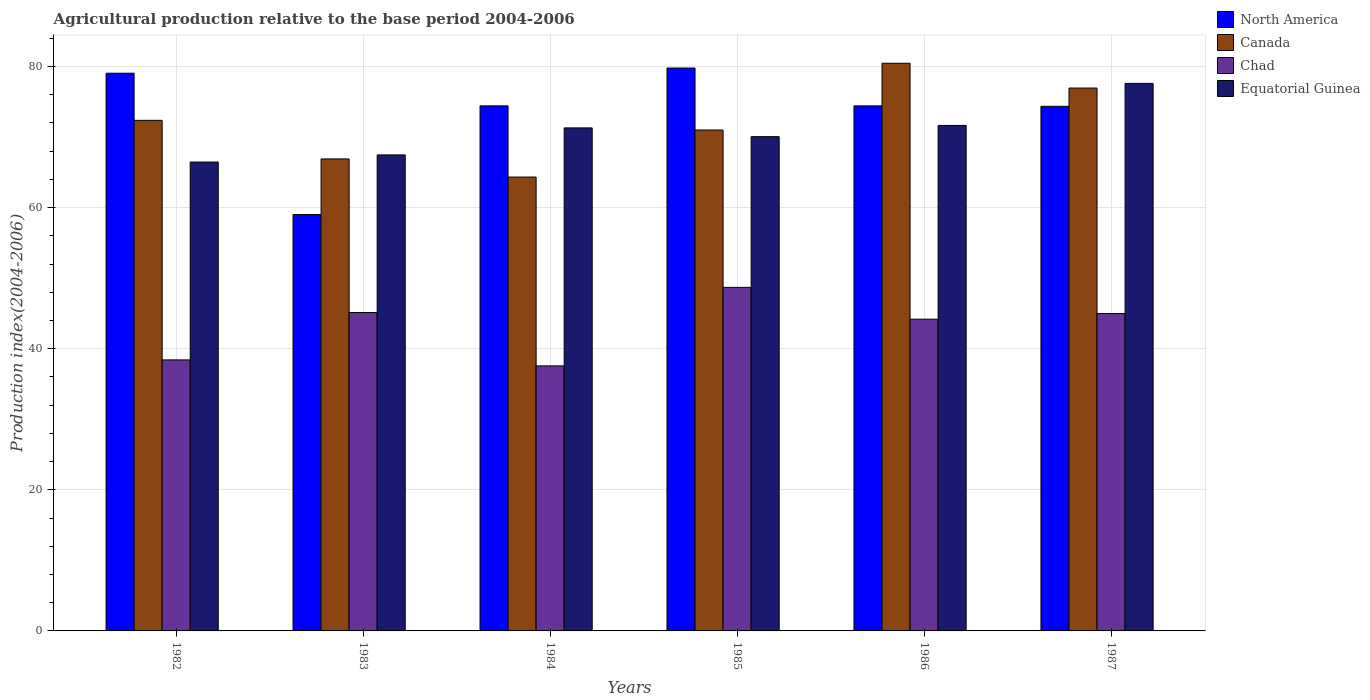How many different coloured bars are there?
Ensure brevity in your answer.  4. How many groups of bars are there?
Offer a terse response. 6. In how many cases, is the number of bars for a given year not equal to the number of legend labels?
Offer a terse response. 0. What is the agricultural production index in North America in 1985?
Ensure brevity in your answer.  79.77. Across all years, what is the maximum agricultural production index in North America?
Give a very brief answer. 79.77. Across all years, what is the minimum agricultural production index in North America?
Your response must be concise. 59.01. What is the total agricultural production index in Chad in the graph?
Provide a succinct answer. 258.94. What is the difference between the agricultural production index in Canada in 1986 and that in 1987?
Provide a short and direct response. 3.51. What is the difference between the agricultural production index in Canada in 1985 and the agricultural production index in Equatorial Guinea in 1984?
Keep it short and to the point. -0.3. What is the average agricultural production index in Canada per year?
Make the answer very short. 71.99. In the year 1983, what is the difference between the agricultural production index in Equatorial Guinea and agricultural production index in Chad?
Offer a terse response. 22.34. What is the ratio of the agricultural production index in North America in 1985 to that in 1986?
Ensure brevity in your answer.  1.07. What is the difference between the highest and the second highest agricultural production index in Equatorial Guinea?
Your answer should be very brief. 5.96. What is the difference between the highest and the lowest agricultural production index in Canada?
Offer a terse response. 16.13. Is the sum of the agricultural production index in North America in 1982 and 1983 greater than the maximum agricultural production index in Chad across all years?
Provide a succinct answer. Yes. What does the 4th bar from the left in 1983 represents?
Provide a succinct answer. Equatorial Guinea. How many years are there in the graph?
Provide a succinct answer. 6. What is the difference between two consecutive major ticks on the Y-axis?
Offer a terse response. 20. Does the graph contain any zero values?
Your response must be concise. No. Where does the legend appear in the graph?
Your answer should be compact. Top right. How many legend labels are there?
Offer a very short reply. 4. What is the title of the graph?
Make the answer very short. Agricultural production relative to the base period 2004-2006. What is the label or title of the Y-axis?
Offer a terse response. Production index(2004-2006). What is the Production index(2004-2006) of North America in 1982?
Offer a very short reply. 79.04. What is the Production index(2004-2006) of Canada in 1982?
Keep it short and to the point. 72.36. What is the Production index(2004-2006) in Chad in 1982?
Provide a succinct answer. 38.41. What is the Production index(2004-2006) of Equatorial Guinea in 1982?
Offer a terse response. 66.45. What is the Production index(2004-2006) of North America in 1983?
Your answer should be very brief. 59.01. What is the Production index(2004-2006) of Canada in 1983?
Offer a very short reply. 66.89. What is the Production index(2004-2006) in Chad in 1983?
Your answer should be compact. 45.12. What is the Production index(2004-2006) in Equatorial Guinea in 1983?
Your answer should be very brief. 67.46. What is the Production index(2004-2006) in North America in 1984?
Give a very brief answer. 74.41. What is the Production index(2004-2006) in Canada in 1984?
Offer a very short reply. 64.32. What is the Production index(2004-2006) in Chad in 1984?
Offer a terse response. 37.56. What is the Production index(2004-2006) in Equatorial Guinea in 1984?
Make the answer very short. 71.29. What is the Production index(2004-2006) of North America in 1985?
Offer a very short reply. 79.77. What is the Production index(2004-2006) of Canada in 1985?
Keep it short and to the point. 70.99. What is the Production index(2004-2006) of Chad in 1985?
Ensure brevity in your answer.  48.69. What is the Production index(2004-2006) of Equatorial Guinea in 1985?
Provide a succinct answer. 70.05. What is the Production index(2004-2006) of North America in 1986?
Provide a short and direct response. 74.41. What is the Production index(2004-2006) in Canada in 1986?
Your answer should be very brief. 80.45. What is the Production index(2004-2006) of Chad in 1986?
Provide a succinct answer. 44.18. What is the Production index(2004-2006) of Equatorial Guinea in 1986?
Provide a succinct answer. 71.64. What is the Production index(2004-2006) of North America in 1987?
Offer a terse response. 74.35. What is the Production index(2004-2006) of Canada in 1987?
Keep it short and to the point. 76.94. What is the Production index(2004-2006) in Chad in 1987?
Offer a very short reply. 44.98. What is the Production index(2004-2006) of Equatorial Guinea in 1987?
Your answer should be compact. 77.6. Across all years, what is the maximum Production index(2004-2006) of North America?
Keep it short and to the point. 79.77. Across all years, what is the maximum Production index(2004-2006) in Canada?
Offer a very short reply. 80.45. Across all years, what is the maximum Production index(2004-2006) in Chad?
Your response must be concise. 48.69. Across all years, what is the maximum Production index(2004-2006) in Equatorial Guinea?
Your response must be concise. 77.6. Across all years, what is the minimum Production index(2004-2006) of North America?
Provide a succinct answer. 59.01. Across all years, what is the minimum Production index(2004-2006) in Canada?
Your answer should be very brief. 64.32. Across all years, what is the minimum Production index(2004-2006) of Chad?
Give a very brief answer. 37.56. Across all years, what is the minimum Production index(2004-2006) of Equatorial Guinea?
Give a very brief answer. 66.45. What is the total Production index(2004-2006) of North America in the graph?
Provide a succinct answer. 440.99. What is the total Production index(2004-2006) of Canada in the graph?
Offer a very short reply. 431.95. What is the total Production index(2004-2006) of Chad in the graph?
Ensure brevity in your answer.  258.94. What is the total Production index(2004-2006) of Equatorial Guinea in the graph?
Your response must be concise. 424.49. What is the difference between the Production index(2004-2006) in North America in 1982 and that in 1983?
Your answer should be compact. 20.03. What is the difference between the Production index(2004-2006) of Canada in 1982 and that in 1983?
Your response must be concise. 5.47. What is the difference between the Production index(2004-2006) in Chad in 1982 and that in 1983?
Make the answer very short. -6.71. What is the difference between the Production index(2004-2006) of Equatorial Guinea in 1982 and that in 1983?
Keep it short and to the point. -1.01. What is the difference between the Production index(2004-2006) in North America in 1982 and that in 1984?
Make the answer very short. 4.63. What is the difference between the Production index(2004-2006) in Canada in 1982 and that in 1984?
Give a very brief answer. 8.04. What is the difference between the Production index(2004-2006) in Chad in 1982 and that in 1984?
Provide a short and direct response. 0.85. What is the difference between the Production index(2004-2006) of Equatorial Guinea in 1982 and that in 1984?
Your answer should be very brief. -4.84. What is the difference between the Production index(2004-2006) in North America in 1982 and that in 1985?
Provide a short and direct response. -0.74. What is the difference between the Production index(2004-2006) of Canada in 1982 and that in 1985?
Provide a short and direct response. 1.37. What is the difference between the Production index(2004-2006) of Chad in 1982 and that in 1985?
Your answer should be compact. -10.28. What is the difference between the Production index(2004-2006) in North America in 1982 and that in 1986?
Offer a terse response. 4.63. What is the difference between the Production index(2004-2006) of Canada in 1982 and that in 1986?
Ensure brevity in your answer.  -8.09. What is the difference between the Production index(2004-2006) of Chad in 1982 and that in 1986?
Offer a very short reply. -5.77. What is the difference between the Production index(2004-2006) in Equatorial Guinea in 1982 and that in 1986?
Provide a succinct answer. -5.19. What is the difference between the Production index(2004-2006) of North America in 1982 and that in 1987?
Offer a very short reply. 4.69. What is the difference between the Production index(2004-2006) in Canada in 1982 and that in 1987?
Ensure brevity in your answer.  -4.58. What is the difference between the Production index(2004-2006) of Chad in 1982 and that in 1987?
Provide a succinct answer. -6.57. What is the difference between the Production index(2004-2006) in Equatorial Guinea in 1982 and that in 1987?
Provide a succinct answer. -11.15. What is the difference between the Production index(2004-2006) in North America in 1983 and that in 1984?
Ensure brevity in your answer.  -15.4. What is the difference between the Production index(2004-2006) in Canada in 1983 and that in 1984?
Your response must be concise. 2.57. What is the difference between the Production index(2004-2006) of Chad in 1983 and that in 1984?
Offer a terse response. 7.56. What is the difference between the Production index(2004-2006) in Equatorial Guinea in 1983 and that in 1984?
Your response must be concise. -3.83. What is the difference between the Production index(2004-2006) of North America in 1983 and that in 1985?
Ensure brevity in your answer.  -20.76. What is the difference between the Production index(2004-2006) of Chad in 1983 and that in 1985?
Your answer should be compact. -3.57. What is the difference between the Production index(2004-2006) in Equatorial Guinea in 1983 and that in 1985?
Your answer should be very brief. -2.59. What is the difference between the Production index(2004-2006) of North America in 1983 and that in 1986?
Provide a short and direct response. -15.4. What is the difference between the Production index(2004-2006) of Canada in 1983 and that in 1986?
Provide a short and direct response. -13.56. What is the difference between the Production index(2004-2006) in Equatorial Guinea in 1983 and that in 1986?
Your answer should be very brief. -4.18. What is the difference between the Production index(2004-2006) of North America in 1983 and that in 1987?
Offer a terse response. -15.34. What is the difference between the Production index(2004-2006) of Canada in 1983 and that in 1987?
Offer a terse response. -10.05. What is the difference between the Production index(2004-2006) in Chad in 1983 and that in 1987?
Your answer should be very brief. 0.14. What is the difference between the Production index(2004-2006) in Equatorial Guinea in 1983 and that in 1987?
Keep it short and to the point. -10.14. What is the difference between the Production index(2004-2006) of North America in 1984 and that in 1985?
Give a very brief answer. -5.36. What is the difference between the Production index(2004-2006) in Canada in 1984 and that in 1985?
Your answer should be compact. -6.67. What is the difference between the Production index(2004-2006) in Chad in 1984 and that in 1985?
Keep it short and to the point. -11.13. What is the difference between the Production index(2004-2006) of Equatorial Guinea in 1984 and that in 1985?
Offer a terse response. 1.24. What is the difference between the Production index(2004-2006) of North America in 1984 and that in 1986?
Your response must be concise. 0. What is the difference between the Production index(2004-2006) of Canada in 1984 and that in 1986?
Offer a terse response. -16.13. What is the difference between the Production index(2004-2006) of Chad in 1984 and that in 1986?
Your answer should be compact. -6.62. What is the difference between the Production index(2004-2006) of Equatorial Guinea in 1984 and that in 1986?
Your answer should be very brief. -0.35. What is the difference between the Production index(2004-2006) in North America in 1984 and that in 1987?
Give a very brief answer. 0.06. What is the difference between the Production index(2004-2006) of Canada in 1984 and that in 1987?
Keep it short and to the point. -12.62. What is the difference between the Production index(2004-2006) in Chad in 1984 and that in 1987?
Your response must be concise. -7.42. What is the difference between the Production index(2004-2006) in Equatorial Guinea in 1984 and that in 1987?
Your response must be concise. -6.31. What is the difference between the Production index(2004-2006) of North America in 1985 and that in 1986?
Your answer should be very brief. 5.37. What is the difference between the Production index(2004-2006) of Canada in 1985 and that in 1986?
Keep it short and to the point. -9.46. What is the difference between the Production index(2004-2006) in Chad in 1985 and that in 1986?
Offer a very short reply. 4.51. What is the difference between the Production index(2004-2006) of Equatorial Guinea in 1985 and that in 1986?
Offer a very short reply. -1.59. What is the difference between the Production index(2004-2006) in North America in 1985 and that in 1987?
Provide a short and direct response. 5.43. What is the difference between the Production index(2004-2006) in Canada in 1985 and that in 1987?
Your answer should be very brief. -5.95. What is the difference between the Production index(2004-2006) of Chad in 1985 and that in 1987?
Make the answer very short. 3.71. What is the difference between the Production index(2004-2006) of Equatorial Guinea in 1985 and that in 1987?
Give a very brief answer. -7.55. What is the difference between the Production index(2004-2006) in North America in 1986 and that in 1987?
Your answer should be very brief. 0.06. What is the difference between the Production index(2004-2006) of Canada in 1986 and that in 1987?
Offer a very short reply. 3.51. What is the difference between the Production index(2004-2006) in Chad in 1986 and that in 1987?
Your response must be concise. -0.8. What is the difference between the Production index(2004-2006) of Equatorial Guinea in 1986 and that in 1987?
Offer a terse response. -5.96. What is the difference between the Production index(2004-2006) in North America in 1982 and the Production index(2004-2006) in Canada in 1983?
Give a very brief answer. 12.15. What is the difference between the Production index(2004-2006) in North America in 1982 and the Production index(2004-2006) in Chad in 1983?
Provide a short and direct response. 33.92. What is the difference between the Production index(2004-2006) in North America in 1982 and the Production index(2004-2006) in Equatorial Guinea in 1983?
Give a very brief answer. 11.58. What is the difference between the Production index(2004-2006) of Canada in 1982 and the Production index(2004-2006) of Chad in 1983?
Provide a short and direct response. 27.24. What is the difference between the Production index(2004-2006) of Canada in 1982 and the Production index(2004-2006) of Equatorial Guinea in 1983?
Make the answer very short. 4.9. What is the difference between the Production index(2004-2006) of Chad in 1982 and the Production index(2004-2006) of Equatorial Guinea in 1983?
Ensure brevity in your answer.  -29.05. What is the difference between the Production index(2004-2006) of North America in 1982 and the Production index(2004-2006) of Canada in 1984?
Offer a very short reply. 14.72. What is the difference between the Production index(2004-2006) of North America in 1982 and the Production index(2004-2006) of Chad in 1984?
Your answer should be compact. 41.48. What is the difference between the Production index(2004-2006) of North America in 1982 and the Production index(2004-2006) of Equatorial Guinea in 1984?
Ensure brevity in your answer.  7.75. What is the difference between the Production index(2004-2006) of Canada in 1982 and the Production index(2004-2006) of Chad in 1984?
Your answer should be very brief. 34.8. What is the difference between the Production index(2004-2006) of Canada in 1982 and the Production index(2004-2006) of Equatorial Guinea in 1984?
Provide a short and direct response. 1.07. What is the difference between the Production index(2004-2006) of Chad in 1982 and the Production index(2004-2006) of Equatorial Guinea in 1984?
Provide a short and direct response. -32.88. What is the difference between the Production index(2004-2006) of North America in 1982 and the Production index(2004-2006) of Canada in 1985?
Make the answer very short. 8.05. What is the difference between the Production index(2004-2006) in North America in 1982 and the Production index(2004-2006) in Chad in 1985?
Your response must be concise. 30.35. What is the difference between the Production index(2004-2006) of North America in 1982 and the Production index(2004-2006) of Equatorial Guinea in 1985?
Offer a terse response. 8.99. What is the difference between the Production index(2004-2006) of Canada in 1982 and the Production index(2004-2006) of Chad in 1985?
Ensure brevity in your answer.  23.67. What is the difference between the Production index(2004-2006) in Canada in 1982 and the Production index(2004-2006) in Equatorial Guinea in 1985?
Your response must be concise. 2.31. What is the difference between the Production index(2004-2006) in Chad in 1982 and the Production index(2004-2006) in Equatorial Guinea in 1985?
Ensure brevity in your answer.  -31.64. What is the difference between the Production index(2004-2006) of North America in 1982 and the Production index(2004-2006) of Canada in 1986?
Provide a succinct answer. -1.41. What is the difference between the Production index(2004-2006) in North America in 1982 and the Production index(2004-2006) in Chad in 1986?
Your answer should be very brief. 34.86. What is the difference between the Production index(2004-2006) in North America in 1982 and the Production index(2004-2006) in Equatorial Guinea in 1986?
Give a very brief answer. 7.4. What is the difference between the Production index(2004-2006) of Canada in 1982 and the Production index(2004-2006) of Chad in 1986?
Ensure brevity in your answer.  28.18. What is the difference between the Production index(2004-2006) of Canada in 1982 and the Production index(2004-2006) of Equatorial Guinea in 1986?
Offer a terse response. 0.72. What is the difference between the Production index(2004-2006) in Chad in 1982 and the Production index(2004-2006) in Equatorial Guinea in 1986?
Offer a very short reply. -33.23. What is the difference between the Production index(2004-2006) in North America in 1982 and the Production index(2004-2006) in Canada in 1987?
Your answer should be compact. 2.1. What is the difference between the Production index(2004-2006) in North America in 1982 and the Production index(2004-2006) in Chad in 1987?
Offer a terse response. 34.06. What is the difference between the Production index(2004-2006) in North America in 1982 and the Production index(2004-2006) in Equatorial Guinea in 1987?
Offer a very short reply. 1.44. What is the difference between the Production index(2004-2006) of Canada in 1982 and the Production index(2004-2006) of Chad in 1987?
Ensure brevity in your answer.  27.38. What is the difference between the Production index(2004-2006) in Canada in 1982 and the Production index(2004-2006) in Equatorial Guinea in 1987?
Your answer should be compact. -5.24. What is the difference between the Production index(2004-2006) of Chad in 1982 and the Production index(2004-2006) of Equatorial Guinea in 1987?
Provide a succinct answer. -39.19. What is the difference between the Production index(2004-2006) of North America in 1983 and the Production index(2004-2006) of Canada in 1984?
Ensure brevity in your answer.  -5.31. What is the difference between the Production index(2004-2006) of North America in 1983 and the Production index(2004-2006) of Chad in 1984?
Keep it short and to the point. 21.45. What is the difference between the Production index(2004-2006) of North America in 1983 and the Production index(2004-2006) of Equatorial Guinea in 1984?
Provide a succinct answer. -12.28. What is the difference between the Production index(2004-2006) of Canada in 1983 and the Production index(2004-2006) of Chad in 1984?
Ensure brevity in your answer.  29.33. What is the difference between the Production index(2004-2006) of Chad in 1983 and the Production index(2004-2006) of Equatorial Guinea in 1984?
Offer a terse response. -26.17. What is the difference between the Production index(2004-2006) in North America in 1983 and the Production index(2004-2006) in Canada in 1985?
Ensure brevity in your answer.  -11.98. What is the difference between the Production index(2004-2006) of North America in 1983 and the Production index(2004-2006) of Chad in 1985?
Make the answer very short. 10.32. What is the difference between the Production index(2004-2006) of North America in 1983 and the Production index(2004-2006) of Equatorial Guinea in 1985?
Keep it short and to the point. -11.04. What is the difference between the Production index(2004-2006) of Canada in 1983 and the Production index(2004-2006) of Chad in 1985?
Keep it short and to the point. 18.2. What is the difference between the Production index(2004-2006) of Canada in 1983 and the Production index(2004-2006) of Equatorial Guinea in 1985?
Ensure brevity in your answer.  -3.16. What is the difference between the Production index(2004-2006) in Chad in 1983 and the Production index(2004-2006) in Equatorial Guinea in 1985?
Provide a succinct answer. -24.93. What is the difference between the Production index(2004-2006) in North America in 1983 and the Production index(2004-2006) in Canada in 1986?
Ensure brevity in your answer.  -21.44. What is the difference between the Production index(2004-2006) of North America in 1983 and the Production index(2004-2006) of Chad in 1986?
Provide a succinct answer. 14.83. What is the difference between the Production index(2004-2006) in North America in 1983 and the Production index(2004-2006) in Equatorial Guinea in 1986?
Your answer should be compact. -12.63. What is the difference between the Production index(2004-2006) of Canada in 1983 and the Production index(2004-2006) of Chad in 1986?
Provide a succinct answer. 22.71. What is the difference between the Production index(2004-2006) in Canada in 1983 and the Production index(2004-2006) in Equatorial Guinea in 1986?
Offer a very short reply. -4.75. What is the difference between the Production index(2004-2006) of Chad in 1983 and the Production index(2004-2006) of Equatorial Guinea in 1986?
Provide a short and direct response. -26.52. What is the difference between the Production index(2004-2006) of North America in 1983 and the Production index(2004-2006) of Canada in 1987?
Your response must be concise. -17.93. What is the difference between the Production index(2004-2006) in North America in 1983 and the Production index(2004-2006) in Chad in 1987?
Give a very brief answer. 14.03. What is the difference between the Production index(2004-2006) in North America in 1983 and the Production index(2004-2006) in Equatorial Guinea in 1987?
Your answer should be very brief. -18.59. What is the difference between the Production index(2004-2006) in Canada in 1983 and the Production index(2004-2006) in Chad in 1987?
Provide a succinct answer. 21.91. What is the difference between the Production index(2004-2006) in Canada in 1983 and the Production index(2004-2006) in Equatorial Guinea in 1987?
Provide a succinct answer. -10.71. What is the difference between the Production index(2004-2006) of Chad in 1983 and the Production index(2004-2006) of Equatorial Guinea in 1987?
Your answer should be compact. -32.48. What is the difference between the Production index(2004-2006) of North America in 1984 and the Production index(2004-2006) of Canada in 1985?
Give a very brief answer. 3.42. What is the difference between the Production index(2004-2006) in North America in 1984 and the Production index(2004-2006) in Chad in 1985?
Offer a very short reply. 25.72. What is the difference between the Production index(2004-2006) of North America in 1984 and the Production index(2004-2006) of Equatorial Guinea in 1985?
Keep it short and to the point. 4.36. What is the difference between the Production index(2004-2006) in Canada in 1984 and the Production index(2004-2006) in Chad in 1985?
Give a very brief answer. 15.63. What is the difference between the Production index(2004-2006) in Canada in 1984 and the Production index(2004-2006) in Equatorial Guinea in 1985?
Provide a succinct answer. -5.73. What is the difference between the Production index(2004-2006) in Chad in 1984 and the Production index(2004-2006) in Equatorial Guinea in 1985?
Provide a succinct answer. -32.49. What is the difference between the Production index(2004-2006) in North America in 1984 and the Production index(2004-2006) in Canada in 1986?
Give a very brief answer. -6.04. What is the difference between the Production index(2004-2006) in North America in 1984 and the Production index(2004-2006) in Chad in 1986?
Provide a succinct answer. 30.23. What is the difference between the Production index(2004-2006) of North America in 1984 and the Production index(2004-2006) of Equatorial Guinea in 1986?
Offer a very short reply. 2.77. What is the difference between the Production index(2004-2006) of Canada in 1984 and the Production index(2004-2006) of Chad in 1986?
Provide a succinct answer. 20.14. What is the difference between the Production index(2004-2006) in Canada in 1984 and the Production index(2004-2006) in Equatorial Guinea in 1986?
Keep it short and to the point. -7.32. What is the difference between the Production index(2004-2006) of Chad in 1984 and the Production index(2004-2006) of Equatorial Guinea in 1986?
Keep it short and to the point. -34.08. What is the difference between the Production index(2004-2006) in North America in 1984 and the Production index(2004-2006) in Canada in 1987?
Your response must be concise. -2.53. What is the difference between the Production index(2004-2006) in North America in 1984 and the Production index(2004-2006) in Chad in 1987?
Your answer should be compact. 29.43. What is the difference between the Production index(2004-2006) of North America in 1984 and the Production index(2004-2006) of Equatorial Guinea in 1987?
Your answer should be compact. -3.19. What is the difference between the Production index(2004-2006) of Canada in 1984 and the Production index(2004-2006) of Chad in 1987?
Your response must be concise. 19.34. What is the difference between the Production index(2004-2006) of Canada in 1984 and the Production index(2004-2006) of Equatorial Guinea in 1987?
Your response must be concise. -13.28. What is the difference between the Production index(2004-2006) in Chad in 1984 and the Production index(2004-2006) in Equatorial Guinea in 1987?
Keep it short and to the point. -40.04. What is the difference between the Production index(2004-2006) in North America in 1985 and the Production index(2004-2006) in Canada in 1986?
Offer a very short reply. -0.68. What is the difference between the Production index(2004-2006) of North America in 1985 and the Production index(2004-2006) of Chad in 1986?
Your answer should be compact. 35.59. What is the difference between the Production index(2004-2006) in North America in 1985 and the Production index(2004-2006) in Equatorial Guinea in 1986?
Provide a succinct answer. 8.13. What is the difference between the Production index(2004-2006) in Canada in 1985 and the Production index(2004-2006) in Chad in 1986?
Give a very brief answer. 26.81. What is the difference between the Production index(2004-2006) of Canada in 1985 and the Production index(2004-2006) of Equatorial Guinea in 1986?
Make the answer very short. -0.65. What is the difference between the Production index(2004-2006) in Chad in 1985 and the Production index(2004-2006) in Equatorial Guinea in 1986?
Keep it short and to the point. -22.95. What is the difference between the Production index(2004-2006) in North America in 1985 and the Production index(2004-2006) in Canada in 1987?
Make the answer very short. 2.83. What is the difference between the Production index(2004-2006) in North America in 1985 and the Production index(2004-2006) in Chad in 1987?
Your response must be concise. 34.79. What is the difference between the Production index(2004-2006) in North America in 1985 and the Production index(2004-2006) in Equatorial Guinea in 1987?
Make the answer very short. 2.17. What is the difference between the Production index(2004-2006) in Canada in 1985 and the Production index(2004-2006) in Chad in 1987?
Keep it short and to the point. 26.01. What is the difference between the Production index(2004-2006) of Canada in 1985 and the Production index(2004-2006) of Equatorial Guinea in 1987?
Offer a terse response. -6.61. What is the difference between the Production index(2004-2006) of Chad in 1985 and the Production index(2004-2006) of Equatorial Guinea in 1987?
Make the answer very short. -28.91. What is the difference between the Production index(2004-2006) of North America in 1986 and the Production index(2004-2006) of Canada in 1987?
Keep it short and to the point. -2.53. What is the difference between the Production index(2004-2006) of North America in 1986 and the Production index(2004-2006) of Chad in 1987?
Offer a very short reply. 29.43. What is the difference between the Production index(2004-2006) of North America in 1986 and the Production index(2004-2006) of Equatorial Guinea in 1987?
Provide a short and direct response. -3.19. What is the difference between the Production index(2004-2006) in Canada in 1986 and the Production index(2004-2006) in Chad in 1987?
Your answer should be very brief. 35.47. What is the difference between the Production index(2004-2006) of Canada in 1986 and the Production index(2004-2006) of Equatorial Guinea in 1987?
Your answer should be compact. 2.85. What is the difference between the Production index(2004-2006) of Chad in 1986 and the Production index(2004-2006) of Equatorial Guinea in 1987?
Offer a very short reply. -33.42. What is the average Production index(2004-2006) in North America per year?
Keep it short and to the point. 73.5. What is the average Production index(2004-2006) in Canada per year?
Give a very brief answer. 71.99. What is the average Production index(2004-2006) of Chad per year?
Provide a succinct answer. 43.16. What is the average Production index(2004-2006) of Equatorial Guinea per year?
Provide a succinct answer. 70.75. In the year 1982, what is the difference between the Production index(2004-2006) of North America and Production index(2004-2006) of Canada?
Ensure brevity in your answer.  6.68. In the year 1982, what is the difference between the Production index(2004-2006) in North America and Production index(2004-2006) in Chad?
Offer a very short reply. 40.63. In the year 1982, what is the difference between the Production index(2004-2006) in North America and Production index(2004-2006) in Equatorial Guinea?
Provide a succinct answer. 12.59. In the year 1982, what is the difference between the Production index(2004-2006) in Canada and Production index(2004-2006) in Chad?
Make the answer very short. 33.95. In the year 1982, what is the difference between the Production index(2004-2006) of Canada and Production index(2004-2006) of Equatorial Guinea?
Offer a very short reply. 5.91. In the year 1982, what is the difference between the Production index(2004-2006) of Chad and Production index(2004-2006) of Equatorial Guinea?
Ensure brevity in your answer.  -28.04. In the year 1983, what is the difference between the Production index(2004-2006) of North America and Production index(2004-2006) of Canada?
Make the answer very short. -7.88. In the year 1983, what is the difference between the Production index(2004-2006) in North America and Production index(2004-2006) in Chad?
Provide a succinct answer. 13.89. In the year 1983, what is the difference between the Production index(2004-2006) in North America and Production index(2004-2006) in Equatorial Guinea?
Make the answer very short. -8.45. In the year 1983, what is the difference between the Production index(2004-2006) of Canada and Production index(2004-2006) of Chad?
Offer a terse response. 21.77. In the year 1983, what is the difference between the Production index(2004-2006) in Canada and Production index(2004-2006) in Equatorial Guinea?
Your response must be concise. -0.57. In the year 1983, what is the difference between the Production index(2004-2006) in Chad and Production index(2004-2006) in Equatorial Guinea?
Your response must be concise. -22.34. In the year 1984, what is the difference between the Production index(2004-2006) of North America and Production index(2004-2006) of Canada?
Your answer should be very brief. 10.09. In the year 1984, what is the difference between the Production index(2004-2006) in North America and Production index(2004-2006) in Chad?
Ensure brevity in your answer.  36.85. In the year 1984, what is the difference between the Production index(2004-2006) in North America and Production index(2004-2006) in Equatorial Guinea?
Your answer should be very brief. 3.12. In the year 1984, what is the difference between the Production index(2004-2006) of Canada and Production index(2004-2006) of Chad?
Offer a very short reply. 26.76. In the year 1984, what is the difference between the Production index(2004-2006) of Canada and Production index(2004-2006) of Equatorial Guinea?
Keep it short and to the point. -6.97. In the year 1984, what is the difference between the Production index(2004-2006) in Chad and Production index(2004-2006) in Equatorial Guinea?
Give a very brief answer. -33.73. In the year 1985, what is the difference between the Production index(2004-2006) in North America and Production index(2004-2006) in Canada?
Give a very brief answer. 8.78. In the year 1985, what is the difference between the Production index(2004-2006) in North America and Production index(2004-2006) in Chad?
Offer a very short reply. 31.08. In the year 1985, what is the difference between the Production index(2004-2006) in North America and Production index(2004-2006) in Equatorial Guinea?
Offer a very short reply. 9.72. In the year 1985, what is the difference between the Production index(2004-2006) in Canada and Production index(2004-2006) in Chad?
Your response must be concise. 22.3. In the year 1985, what is the difference between the Production index(2004-2006) in Chad and Production index(2004-2006) in Equatorial Guinea?
Make the answer very short. -21.36. In the year 1986, what is the difference between the Production index(2004-2006) of North America and Production index(2004-2006) of Canada?
Offer a very short reply. -6.04. In the year 1986, what is the difference between the Production index(2004-2006) in North America and Production index(2004-2006) in Chad?
Offer a very short reply. 30.23. In the year 1986, what is the difference between the Production index(2004-2006) of North America and Production index(2004-2006) of Equatorial Guinea?
Ensure brevity in your answer.  2.77. In the year 1986, what is the difference between the Production index(2004-2006) in Canada and Production index(2004-2006) in Chad?
Your answer should be very brief. 36.27. In the year 1986, what is the difference between the Production index(2004-2006) in Canada and Production index(2004-2006) in Equatorial Guinea?
Provide a succinct answer. 8.81. In the year 1986, what is the difference between the Production index(2004-2006) of Chad and Production index(2004-2006) of Equatorial Guinea?
Your answer should be very brief. -27.46. In the year 1987, what is the difference between the Production index(2004-2006) of North America and Production index(2004-2006) of Canada?
Keep it short and to the point. -2.59. In the year 1987, what is the difference between the Production index(2004-2006) in North America and Production index(2004-2006) in Chad?
Your answer should be very brief. 29.37. In the year 1987, what is the difference between the Production index(2004-2006) in North America and Production index(2004-2006) in Equatorial Guinea?
Provide a short and direct response. -3.25. In the year 1987, what is the difference between the Production index(2004-2006) of Canada and Production index(2004-2006) of Chad?
Give a very brief answer. 31.96. In the year 1987, what is the difference between the Production index(2004-2006) in Canada and Production index(2004-2006) in Equatorial Guinea?
Ensure brevity in your answer.  -0.66. In the year 1987, what is the difference between the Production index(2004-2006) in Chad and Production index(2004-2006) in Equatorial Guinea?
Offer a terse response. -32.62. What is the ratio of the Production index(2004-2006) of North America in 1982 to that in 1983?
Provide a short and direct response. 1.34. What is the ratio of the Production index(2004-2006) of Canada in 1982 to that in 1983?
Give a very brief answer. 1.08. What is the ratio of the Production index(2004-2006) of Chad in 1982 to that in 1983?
Keep it short and to the point. 0.85. What is the ratio of the Production index(2004-2006) in Equatorial Guinea in 1982 to that in 1983?
Your response must be concise. 0.98. What is the ratio of the Production index(2004-2006) of North America in 1982 to that in 1984?
Your response must be concise. 1.06. What is the ratio of the Production index(2004-2006) of Canada in 1982 to that in 1984?
Make the answer very short. 1.12. What is the ratio of the Production index(2004-2006) of Chad in 1982 to that in 1984?
Your answer should be very brief. 1.02. What is the ratio of the Production index(2004-2006) in Equatorial Guinea in 1982 to that in 1984?
Your response must be concise. 0.93. What is the ratio of the Production index(2004-2006) of Canada in 1982 to that in 1985?
Make the answer very short. 1.02. What is the ratio of the Production index(2004-2006) in Chad in 1982 to that in 1985?
Provide a short and direct response. 0.79. What is the ratio of the Production index(2004-2006) of Equatorial Guinea in 1982 to that in 1985?
Your answer should be compact. 0.95. What is the ratio of the Production index(2004-2006) in North America in 1982 to that in 1986?
Your answer should be very brief. 1.06. What is the ratio of the Production index(2004-2006) of Canada in 1982 to that in 1986?
Offer a very short reply. 0.9. What is the ratio of the Production index(2004-2006) of Chad in 1982 to that in 1986?
Make the answer very short. 0.87. What is the ratio of the Production index(2004-2006) in Equatorial Guinea in 1982 to that in 1986?
Keep it short and to the point. 0.93. What is the ratio of the Production index(2004-2006) in North America in 1982 to that in 1987?
Your answer should be compact. 1.06. What is the ratio of the Production index(2004-2006) in Canada in 1982 to that in 1987?
Give a very brief answer. 0.94. What is the ratio of the Production index(2004-2006) of Chad in 1982 to that in 1987?
Your answer should be compact. 0.85. What is the ratio of the Production index(2004-2006) of Equatorial Guinea in 1982 to that in 1987?
Make the answer very short. 0.86. What is the ratio of the Production index(2004-2006) of North America in 1983 to that in 1984?
Keep it short and to the point. 0.79. What is the ratio of the Production index(2004-2006) in Canada in 1983 to that in 1984?
Provide a short and direct response. 1.04. What is the ratio of the Production index(2004-2006) in Chad in 1983 to that in 1984?
Your answer should be compact. 1.2. What is the ratio of the Production index(2004-2006) of Equatorial Guinea in 1983 to that in 1984?
Your answer should be compact. 0.95. What is the ratio of the Production index(2004-2006) in North America in 1983 to that in 1985?
Offer a terse response. 0.74. What is the ratio of the Production index(2004-2006) in Canada in 1983 to that in 1985?
Make the answer very short. 0.94. What is the ratio of the Production index(2004-2006) of Chad in 1983 to that in 1985?
Your response must be concise. 0.93. What is the ratio of the Production index(2004-2006) of Equatorial Guinea in 1983 to that in 1985?
Make the answer very short. 0.96. What is the ratio of the Production index(2004-2006) in North America in 1983 to that in 1986?
Offer a very short reply. 0.79. What is the ratio of the Production index(2004-2006) in Canada in 1983 to that in 1986?
Offer a very short reply. 0.83. What is the ratio of the Production index(2004-2006) in Chad in 1983 to that in 1986?
Your response must be concise. 1.02. What is the ratio of the Production index(2004-2006) of Equatorial Guinea in 1983 to that in 1986?
Keep it short and to the point. 0.94. What is the ratio of the Production index(2004-2006) of North America in 1983 to that in 1987?
Offer a very short reply. 0.79. What is the ratio of the Production index(2004-2006) of Canada in 1983 to that in 1987?
Your answer should be compact. 0.87. What is the ratio of the Production index(2004-2006) in Equatorial Guinea in 1983 to that in 1987?
Ensure brevity in your answer.  0.87. What is the ratio of the Production index(2004-2006) in North America in 1984 to that in 1985?
Your answer should be compact. 0.93. What is the ratio of the Production index(2004-2006) in Canada in 1984 to that in 1985?
Keep it short and to the point. 0.91. What is the ratio of the Production index(2004-2006) of Chad in 1984 to that in 1985?
Make the answer very short. 0.77. What is the ratio of the Production index(2004-2006) of Equatorial Guinea in 1984 to that in 1985?
Make the answer very short. 1.02. What is the ratio of the Production index(2004-2006) of North America in 1984 to that in 1986?
Ensure brevity in your answer.  1. What is the ratio of the Production index(2004-2006) of Canada in 1984 to that in 1986?
Your response must be concise. 0.8. What is the ratio of the Production index(2004-2006) of Chad in 1984 to that in 1986?
Provide a succinct answer. 0.85. What is the ratio of the Production index(2004-2006) in Canada in 1984 to that in 1987?
Make the answer very short. 0.84. What is the ratio of the Production index(2004-2006) in Chad in 1984 to that in 1987?
Ensure brevity in your answer.  0.83. What is the ratio of the Production index(2004-2006) of Equatorial Guinea in 1984 to that in 1987?
Provide a short and direct response. 0.92. What is the ratio of the Production index(2004-2006) in North America in 1985 to that in 1986?
Make the answer very short. 1.07. What is the ratio of the Production index(2004-2006) in Canada in 1985 to that in 1986?
Provide a succinct answer. 0.88. What is the ratio of the Production index(2004-2006) of Chad in 1985 to that in 1986?
Your answer should be very brief. 1.1. What is the ratio of the Production index(2004-2006) of Equatorial Guinea in 1985 to that in 1986?
Provide a short and direct response. 0.98. What is the ratio of the Production index(2004-2006) in North America in 1985 to that in 1987?
Ensure brevity in your answer.  1.07. What is the ratio of the Production index(2004-2006) of Canada in 1985 to that in 1987?
Ensure brevity in your answer.  0.92. What is the ratio of the Production index(2004-2006) of Chad in 1985 to that in 1987?
Your answer should be very brief. 1.08. What is the ratio of the Production index(2004-2006) of Equatorial Guinea in 1985 to that in 1987?
Give a very brief answer. 0.9. What is the ratio of the Production index(2004-2006) of North America in 1986 to that in 1987?
Offer a very short reply. 1. What is the ratio of the Production index(2004-2006) in Canada in 1986 to that in 1987?
Keep it short and to the point. 1.05. What is the ratio of the Production index(2004-2006) of Chad in 1986 to that in 1987?
Provide a short and direct response. 0.98. What is the ratio of the Production index(2004-2006) in Equatorial Guinea in 1986 to that in 1987?
Ensure brevity in your answer.  0.92. What is the difference between the highest and the second highest Production index(2004-2006) of North America?
Keep it short and to the point. 0.74. What is the difference between the highest and the second highest Production index(2004-2006) of Canada?
Your answer should be compact. 3.51. What is the difference between the highest and the second highest Production index(2004-2006) of Chad?
Give a very brief answer. 3.57. What is the difference between the highest and the second highest Production index(2004-2006) in Equatorial Guinea?
Offer a very short reply. 5.96. What is the difference between the highest and the lowest Production index(2004-2006) in North America?
Give a very brief answer. 20.76. What is the difference between the highest and the lowest Production index(2004-2006) in Canada?
Provide a short and direct response. 16.13. What is the difference between the highest and the lowest Production index(2004-2006) of Chad?
Provide a short and direct response. 11.13. What is the difference between the highest and the lowest Production index(2004-2006) of Equatorial Guinea?
Your answer should be compact. 11.15. 